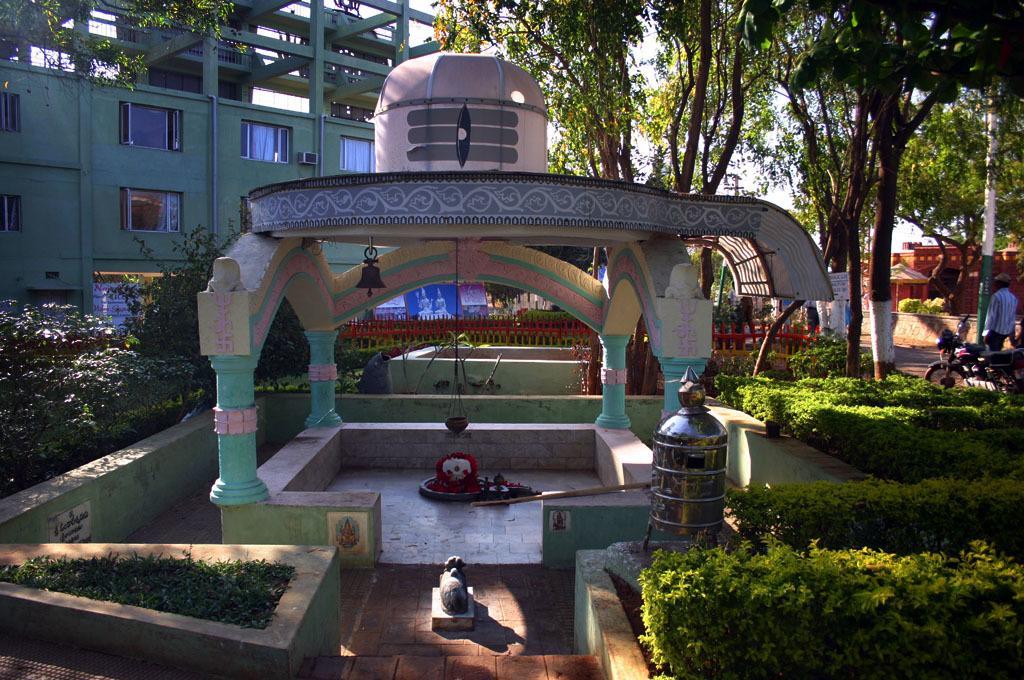Describe this image in one or two sentences. In this image I can see few plants, some grass, a metal box, a motor bike, a person standing, few trees and few buildings. In the background I can see the sky. 